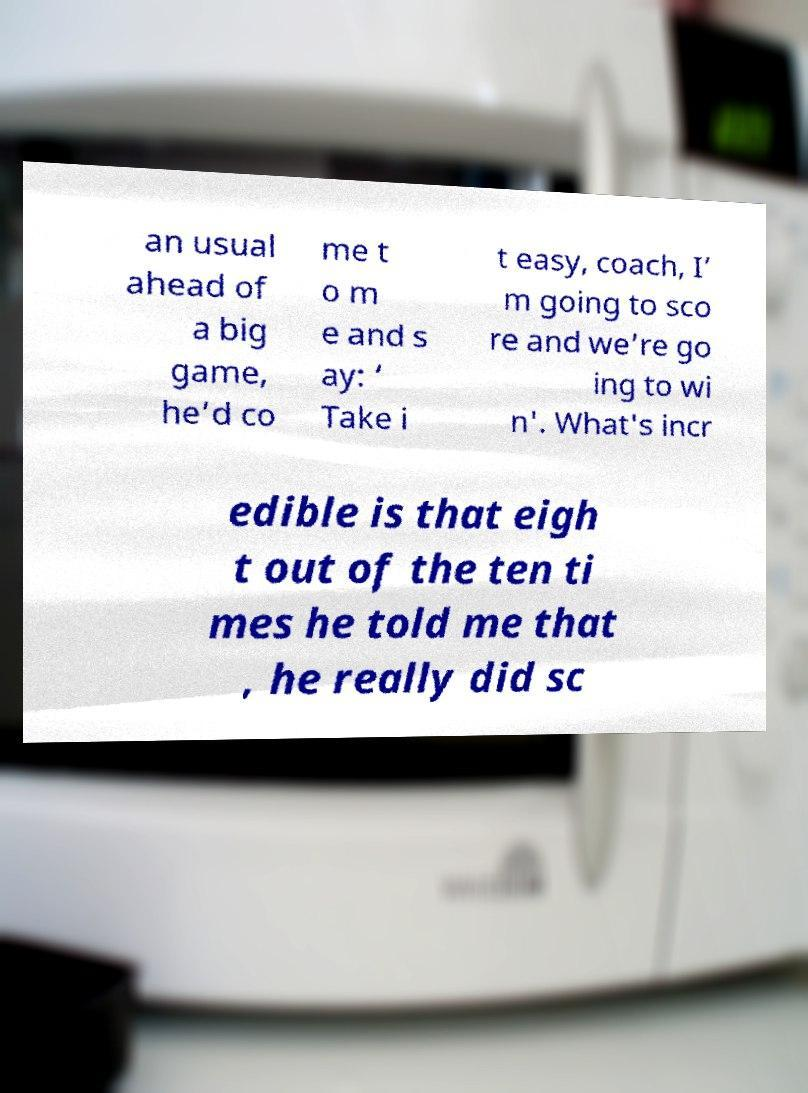Could you assist in decoding the text presented in this image and type it out clearly? an usual ahead of a big game, he’d co me t o m e and s ay: ‘ Take i t easy, coach, I’ m going to sco re and we’re go ing to wi n'. What's incr edible is that eigh t out of the ten ti mes he told me that , he really did sc 